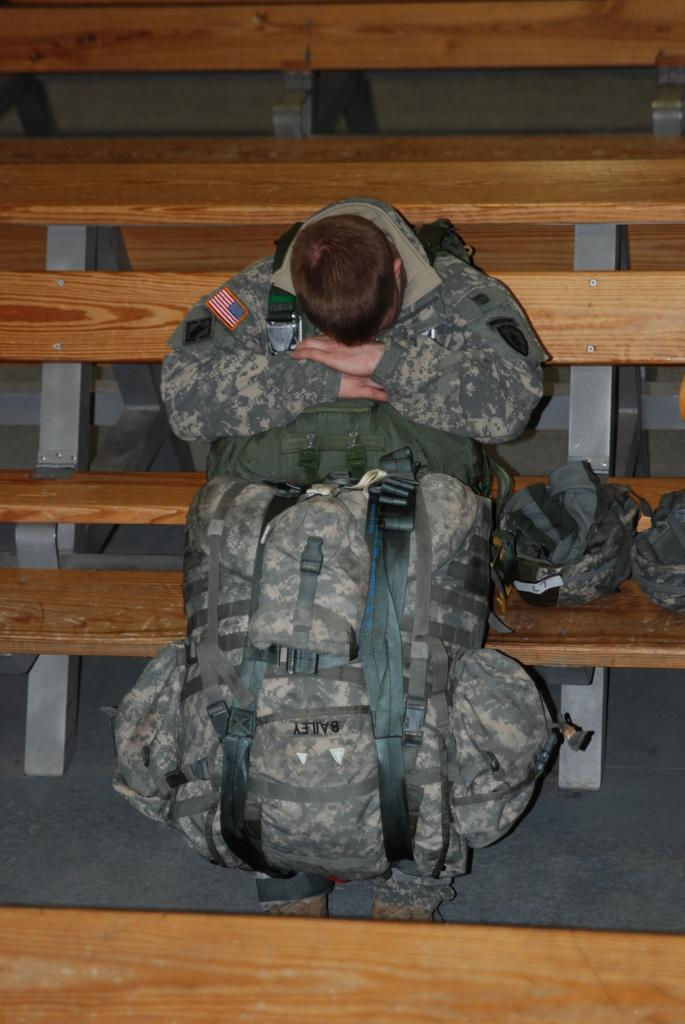Who is the main subject in the image? There is a man in the image. What is the man doing in the image? The man is sitting. What is the man holding in the image? The man is holding a bag. What memory does the man have about the bag in the image? There is no information about the man's memory or any specific memory related to the bag in the image. 